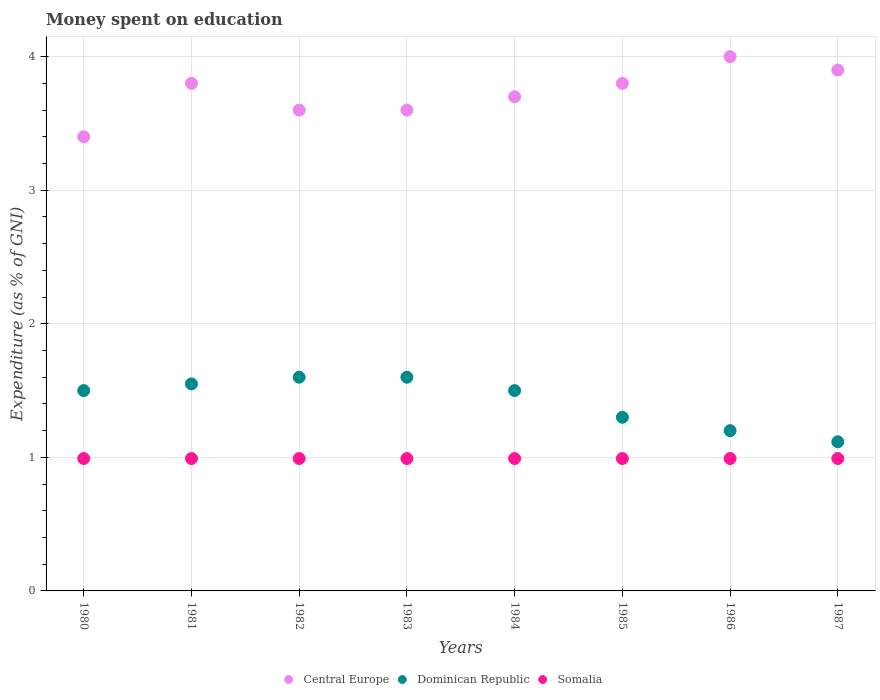Is the number of dotlines equal to the number of legend labels?
Your response must be concise. Yes. What is the amount of money spent on education in Central Europe in 1980?
Your response must be concise. 3.4. Across all years, what is the minimum amount of money spent on education in Dominican Republic?
Provide a succinct answer. 1.12. What is the total amount of money spent on education in Somalia in the graph?
Your answer should be very brief. 7.93. What is the difference between the amount of money spent on education in Dominican Republic in 1984 and the amount of money spent on education in Somalia in 1987?
Your answer should be very brief. 0.51. What is the average amount of money spent on education in Central Europe per year?
Ensure brevity in your answer.  3.72. In the year 1987, what is the difference between the amount of money spent on education in Somalia and amount of money spent on education in Central Europe?
Your answer should be very brief. -2.91. In how many years, is the amount of money spent on education in Dominican Republic greater than 2.8 %?
Offer a very short reply. 0. Is the amount of money spent on education in Dominican Republic in 1981 less than that in 1983?
Make the answer very short. Yes. Is the difference between the amount of money spent on education in Somalia in 1983 and 1986 greater than the difference between the amount of money spent on education in Central Europe in 1983 and 1986?
Make the answer very short. Yes. Is the sum of the amount of money spent on education in Somalia in 1980 and 1983 greater than the maximum amount of money spent on education in Dominican Republic across all years?
Ensure brevity in your answer.  Yes. Is it the case that in every year, the sum of the amount of money spent on education in Central Europe and amount of money spent on education in Dominican Republic  is greater than the amount of money spent on education in Somalia?
Your answer should be compact. Yes. Is the amount of money spent on education in Central Europe strictly greater than the amount of money spent on education in Somalia over the years?
Ensure brevity in your answer.  Yes. How many dotlines are there?
Your answer should be very brief. 3. Are the values on the major ticks of Y-axis written in scientific E-notation?
Your answer should be compact. No. Does the graph contain any zero values?
Your answer should be compact. No. Where does the legend appear in the graph?
Your answer should be very brief. Bottom center. How many legend labels are there?
Provide a short and direct response. 3. What is the title of the graph?
Make the answer very short. Money spent on education. Does "Latin America(developing only)" appear as one of the legend labels in the graph?
Provide a succinct answer. No. What is the label or title of the Y-axis?
Give a very brief answer. Expenditure (as % of GNI). What is the Expenditure (as % of GNI) of Central Europe in 1980?
Ensure brevity in your answer.  3.4. What is the Expenditure (as % of GNI) of Dominican Republic in 1980?
Provide a short and direct response. 1.5. What is the Expenditure (as % of GNI) in Somalia in 1980?
Give a very brief answer. 0.99. What is the Expenditure (as % of GNI) in Central Europe in 1981?
Keep it short and to the point. 3.8. What is the Expenditure (as % of GNI) of Dominican Republic in 1981?
Provide a short and direct response. 1.55. What is the Expenditure (as % of GNI) of Somalia in 1981?
Keep it short and to the point. 0.99. What is the Expenditure (as % of GNI) of Central Europe in 1982?
Your response must be concise. 3.6. What is the Expenditure (as % of GNI) of Somalia in 1982?
Ensure brevity in your answer.  0.99. What is the Expenditure (as % of GNI) of Somalia in 1983?
Offer a terse response. 0.99. What is the Expenditure (as % of GNI) in Central Europe in 1984?
Your answer should be compact. 3.7. What is the Expenditure (as % of GNI) of Dominican Republic in 1984?
Your answer should be very brief. 1.5. What is the Expenditure (as % of GNI) of Somalia in 1984?
Your answer should be compact. 0.99. What is the Expenditure (as % of GNI) of Central Europe in 1985?
Your answer should be very brief. 3.8. What is the Expenditure (as % of GNI) in Somalia in 1985?
Your answer should be very brief. 0.99. What is the Expenditure (as % of GNI) of Somalia in 1986?
Your answer should be very brief. 0.99. What is the Expenditure (as % of GNI) of Central Europe in 1987?
Your response must be concise. 3.9. What is the Expenditure (as % of GNI) in Dominican Republic in 1987?
Give a very brief answer. 1.12. What is the Expenditure (as % of GNI) in Somalia in 1987?
Your response must be concise. 0.99. Across all years, what is the maximum Expenditure (as % of GNI) of Somalia?
Give a very brief answer. 0.99. Across all years, what is the minimum Expenditure (as % of GNI) of Central Europe?
Your answer should be very brief. 3.4. Across all years, what is the minimum Expenditure (as % of GNI) in Dominican Republic?
Offer a terse response. 1.12. Across all years, what is the minimum Expenditure (as % of GNI) in Somalia?
Provide a short and direct response. 0.99. What is the total Expenditure (as % of GNI) of Central Europe in the graph?
Provide a short and direct response. 29.8. What is the total Expenditure (as % of GNI) in Dominican Republic in the graph?
Offer a very short reply. 11.37. What is the total Expenditure (as % of GNI) in Somalia in the graph?
Your answer should be compact. 7.93. What is the difference between the Expenditure (as % of GNI) in Somalia in 1980 and that in 1982?
Make the answer very short. 0. What is the difference between the Expenditure (as % of GNI) in Central Europe in 1980 and that in 1983?
Provide a short and direct response. -0.2. What is the difference between the Expenditure (as % of GNI) in Dominican Republic in 1980 and that in 1983?
Offer a very short reply. -0.1. What is the difference between the Expenditure (as % of GNI) in Central Europe in 1980 and that in 1984?
Provide a succinct answer. -0.3. What is the difference between the Expenditure (as % of GNI) in Dominican Republic in 1980 and that in 1984?
Your answer should be very brief. 0. What is the difference between the Expenditure (as % of GNI) of Somalia in 1980 and that in 1984?
Offer a very short reply. 0. What is the difference between the Expenditure (as % of GNI) in Somalia in 1980 and that in 1985?
Give a very brief answer. 0. What is the difference between the Expenditure (as % of GNI) of Central Europe in 1980 and that in 1986?
Provide a succinct answer. -0.6. What is the difference between the Expenditure (as % of GNI) in Dominican Republic in 1980 and that in 1986?
Your response must be concise. 0.3. What is the difference between the Expenditure (as % of GNI) of Somalia in 1980 and that in 1986?
Your response must be concise. 0. What is the difference between the Expenditure (as % of GNI) in Central Europe in 1980 and that in 1987?
Provide a succinct answer. -0.5. What is the difference between the Expenditure (as % of GNI) in Dominican Republic in 1980 and that in 1987?
Your answer should be compact. 0.38. What is the difference between the Expenditure (as % of GNI) in Somalia in 1980 and that in 1987?
Your answer should be very brief. 0. What is the difference between the Expenditure (as % of GNI) in Central Europe in 1981 and that in 1982?
Provide a short and direct response. 0.2. What is the difference between the Expenditure (as % of GNI) in Dominican Republic in 1981 and that in 1982?
Make the answer very short. -0.05. What is the difference between the Expenditure (as % of GNI) in Somalia in 1981 and that in 1983?
Offer a terse response. 0. What is the difference between the Expenditure (as % of GNI) in Central Europe in 1981 and that in 1984?
Keep it short and to the point. 0.1. What is the difference between the Expenditure (as % of GNI) in Dominican Republic in 1981 and that in 1984?
Give a very brief answer. 0.05. What is the difference between the Expenditure (as % of GNI) in Somalia in 1981 and that in 1984?
Your answer should be compact. 0. What is the difference between the Expenditure (as % of GNI) of Central Europe in 1981 and that in 1985?
Make the answer very short. 0. What is the difference between the Expenditure (as % of GNI) of Dominican Republic in 1981 and that in 1985?
Your answer should be compact. 0.25. What is the difference between the Expenditure (as % of GNI) of Dominican Republic in 1981 and that in 1986?
Keep it short and to the point. 0.35. What is the difference between the Expenditure (as % of GNI) in Somalia in 1981 and that in 1986?
Give a very brief answer. 0. What is the difference between the Expenditure (as % of GNI) in Central Europe in 1981 and that in 1987?
Provide a succinct answer. -0.1. What is the difference between the Expenditure (as % of GNI) of Dominican Republic in 1981 and that in 1987?
Your answer should be very brief. 0.43. What is the difference between the Expenditure (as % of GNI) of Central Europe in 1982 and that in 1984?
Your response must be concise. -0.1. What is the difference between the Expenditure (as % of GNI) in Somalia in 1982 and that in 1984?
Give a very brief answer. 0. What is the difference between the Expenditure (as % of GNI) of Central Europe in 1982 and that in 1986?
Make the answer very short. -0.4. What is the difference between the Expenditure (as % of GNI) of Central Europe in 1982 and that in 1987?
Provide a short and direct response. -0.3. What is the difference between the Expenditure (as % of GNI) in Dominican Republic in 1982 and that in 1987?
Provide a succinct answer. 0.48. What is the difference between the Expenditure (as % of GNI) of Central Europe in 1983 and that in 1984?
Ensure brevity in your answer.  -0.1. What is the difference between the Expenditure (as % of GNI) of Central Europe in 1983 and that in 1985?
Ensure brevity in your answer.  -0.2. What is the difference between the Expenditure (as % of GNI) in Dominican Republic in 1983 and that in 1985?
Offer a terse response. 0.3. What is the difference between the Expenditure (as % of GNI) of Somalia in 1983 and that in 1985?
Offer a terse response. 0. What is the difference between the Expenditure (as % of GNI) of Dominican Republic in 1983 and that in 1986?
Give a very brief answer. 0.4. What is the difference between the Expenditure (as % of GNI) in Central Europe in 1983 and that in 1987?
Ensure brevity in your answer.  -0.3. What is the difference between the Expenditure (as % of GNI) of Dominican Republic in 1983 and that in 1987?
Make the answer very short. 0.48. What is the difference between the Expenditure (as % of GNI) of Somalia in 1984 and that in 1985?
Give a very brief answer. 0. What is the difference between the Expenditure (as % of GNI) in Somalia in 1984 and that in 1986?
Offer a very short reply. 0. What is the difference between the Expenditure (as % of GNI) of Central Europe in 1984 and that in 1987?
Give a very brief answer. -0.2. What is the difference between the Expenditure (as % of GNI) in Dominican Republic in 1984 and that in 1987?
Keep it short and to the point. 0.38. What is the difference between the Expenditure (as % of GNI) of Somalia in 1984 and that in 1987?
Provide a short and direct response. 0. What is the difference between the Expenditure (as % of GNI) of Central Europe in 1985 and that in 1986?
Make the answer very short. -0.2. What is the difference between the Expenditure (as % of GNI) in Somalia in 1985 and that in 1986?
Offer a terse response. 0. What is the difference between the Expenditure (as % of GNI) of Central Europe in 1985 and that in 1987?
Ensure brevity in your answer.  -0.1. What is the difference between the Expenditure (as % of GNI) in Dominican Republic in 1985 and that in 1987?
Provide a short and direct response. 0.18. What is the difference between the Expenditure (as % of GNI) of Central Europe in 1986 and that in 1987?
Your answer should be compact. 0.1. What is the difference between the Expenditure (as % of GNI) of Dominican Republic in 1986 and that in 1987?
Provide a succinct answer. 0.08. What is the difference between the Expenditure (as % of GNI) of Somalia in 1986 and that in 1987?
Your answer should be compact. 0. What is the difference between the Expenditure (as % of GNI) in Central Europe in 1980 and the Expenditure (as % of GNI) in Dominican Republic in 1981?
Provide a short and direct response. 1.85. What is the difference between the Expenditure (as % of GNI) of Central Europe in 1980 and the Expenditure (as % of GNI) of Somalia in 1981?
Keep it short and to the point. 2.41. What is the difference between the Expenditure (as % of GNI) of Dominican Republic in 1980 and the Expenditure (as % of GNI) of Somalia in 1981?
Your answer should be compact. 0.51. What is the difference between the Expenditure (as % of GNI) of Central Europe in 1980 and the Expenditure (as % of GNI) of Somalia in 1982?
Your response must be concise. 2.41. What is the difference between the Expenditure (as % of GNI) in Dominican Republic in 1980 and the Expenditure (as % of GNI) in Somalia in 1982?
Keep it short and to the point. 0.51. What is the difference between the Expenditure (as % of GNI) in Central Europe in 1980 and the Expenditure (as % of GNI) in Somalia in 1983?
Provide a succinct answer. 2.41. What is the difference between the Expenditure (as % of GNI) of Dominican Republic in 1980 and the Expenditure (as % of GNI) of Somalia in 1983?
Your answer should be very brief. 0.51. What is the difference between the Expenditure (as % of GNI) in Central Europe in 1980 and the Expenditure (as % of GNI) in Dominican Republic in 1984?
Give a very brief answer. 1.9. What is the difference between the Expenditure (as % of GNI) in Central Europe in 1980 and the Expenditure (as % of GNI) in Somalia in 1984?
Offer a terse response. 2.41. What is the difference between the Expenditure (as % of GNI) in Dominican Republic in 1980 and the Expenditure (as % of GNI) in Somalia in 1984?
Provide a succinct answer. 0.51. What is the difference between the Expenditure (as % of GNI) in Central Europe in 1980 and the Expenditure (as % of GNI) in Somalia in 1985?
Your answer should be compact. 2.41. What is the difference between the Expenditure (as % of GNI) of Dominican Republic in 1980 and the Expenditure (as % of GNI) of Somalia in 1985?
Provide a short and direct response. 0.51. What is the difference between the Expenditure (as % of GNI) of Central Europe in 1980 and the Expenditure (as % of GNI) of Somalia in 1986?
Provide a short and direct response. 2.41. What is the difference between the Expenditure (as % of GNI) of Dominican Republic in 1980 and the Expenditure (as % of GNI) of Somalia in 1986?
Offer a terse response. 0.51. What is the difference between the Expenditure (as % of GNI) of Central Europe in 1980 and the Expenditure (as % of GNI) of Dominican Republic in 1987?
Your answer should be compact. 2.28. What is the difference between the Expenditure (as % of GNI) of Central Europe in 1980 and the Expenditure (as % of GNI) of Somalia in 1987?
Offer a terse response. 2.41. What is the difference between the Expenditure (as % of GNI) in Dominican Republic in 1980 and the Expenditure (as % of GNI) in Somalia in 1987?
Make the answer very short. 0.51. What is the difference between the Expenditure (as % of GNI) in Central Europe in 1981 and the Expenditure (as % of GNI) in Somalia in 1982?
Provide a succinct answer. 2.81. What is the difference between the Expenditure (as % of GNI) of Dominican Republic in 1981 and the Expenditure (as % of GNI) of Somalia in 1982?
Offer a terse response. 0.56. What is the difference between the Expenditure (as % of GNI) of Central Europe in 1981 and the Expenditure (as % of GNI) of Dominican Republic in 1983?
Provide a short and direct response. 2.2. What is the difference between the Expenditure (as % of GNI) in Central Europe in 1981 and the Expenditure (as % of GNI) in Somalia in 1983?
Make the answer very short. 2.81. What is the difference between the Expenditure (as % of GNI) of Dominican Republic in 1981 and the Expenditure (as % of GNI) of Somalia in 1983?
Offer a very short reply. 0.56. What is the difference between the Expenditure (as % of GNI) of Central Europe in 1981 and the Expenditure (as % of GNI) of Dominican Republic in 1984?
Your answer should be very brief. 2.3. What is the difference between the Expenditure (as % of GNI) of Central Europe in 1981 and the Expenditure (as % of GNI) of Somalia in 1984?
Your response must be concise. 2.81. What is the difference between the Expenditure (as % of GNI) of Dominican Republic in 1981 and the Expenditure (as % of GNI) of Somalia in 1984?
Make the answer very short. 0.56. What is the difference between the Expenditure (as % of GNI) of Central Europe in 1981 and the Expenditure (as % of GNI) of Dominican Republic in 1985?
Offer a terse response. 2.5. What is the difference between the Expenditure (as % of GNI) of Central Europe in 1981 and the Expenditure (as % of GNI) of Somalia in 1985?
Your answer should be very brief. 2.81. What is the difference between the Expenditure (as % of GNI) of Dominican Republic in 1981 and the Expenditure (as % of GNI) of Somalia in 1985?
Provide a short and direct response. 0.56. What is the difference between the Expenditure (as % of GNI) of Central Europe in 1981 and the Expenditure (as % of GNI) of Somalia in 1986?
Provide a short and direct response. 2.81. What is the difference between the Expenditure (as % of GNI) in Dominican Republic in 1981 and the Expenditure (as % of GNI) in Somalia in 1986?
Ensure brevity in your answer.  0.56. What is the difference between the Expenditure (as % of GNI) in Central Europe in 1981 and the Expenditure (as % of GNI) in Dominican Republic in 1987?
Your answer should be very brief. 2.68. What is the difference between the Expenditure (as % of GNI) in Central Europe in 1981 and the Expenditure (as % of GNI) in Somalia in 1987?
Your response must be concise. 2.81. What is the difference between the Expenditure (as % of GNI) in Dominican Republic in 1981 and the Expenditure (as % of GNI) in Somalia in 1987?
Offer a very short reply. 0.56. What is the difference between the Expenditure (as % of GNI) of Central Europe in 1982 and the Expenditure (as % of GNI) of Dominican Republic in 1983?
Provide a short and direct response. 2. What is the difference between the Expenditure (as % of GNI) of Central Europe in 1982 and the Expenditure (as % of GNI) of Somalia in 1983?
Ensure brevity in your answer.  2.61. What is the difference between the Expenditure (as % of GNI) of Dominican Republic in 1982 and the Expenditure (as % of GNI) of Somalia in 1983?
Give a very brief answer. 0.61. What is the difference between the Expenditure (as % of GNI) of Central Europe in 1982 and the Expenditure (as % of GNI) of Somalia in 1984?
Ensure brevity in your answer.  2.61. What is the difference between the Expenditure (as % of GNI) of Dominican Republic in 1982 and the Expenditure (as % of GNI) of Somalia in 1984?
Provide a succinct answer. 0.61. What is the difference between the Expenditure (as % of GNI) of Central Europe in 1982 and the Expenditure (as % of GNI) of Dominican Republic in 1985?
Ensure brevity in your answer.  2.3. What is the difference between the Expenditure (as % of GNI) of Central Europe in 1982 and the Expenditure (as % of GNI) of Somalia in 1985?
Your answer should be very brief. 2.61. What is the difference between the Expenditure (as % of GNI) of Dominican Republic in 1982 and the Expenditure (as % of GNI) of Somalia in 1985?
Your answer should be compact. 0.61. What is the difference between the Expenditure (as % of GNI) in Central Europe in 1982 and the Expenditure (as % of GNI) in Somalia in 1986?
Make the answer very short. 2.61. What is the difference between the Expenditure (as % of GNI) of Dominican Republic in 1982 and the Expenditure (as % of GNI) of Somalia in 1986?
Make the answer very short. 0.61. What is the difference between the Expenditure (as % of GNI) in Central Europe in 1982 and the Expenditure (as % of GNI) in Dominican Republic in 1987?
Give a very brief answer. 2.48. What is the difference between the Expenditure (as % of GNI) of Central Europe in 1982 and the Expenditure (as % of GNI) of Somalia in 1987?
Ensure brevity in your answer.  2.61. What is the difference between the Expenditure (as % of GNI) in Dominican Republic in 1982 and the Expenditure (as % of GNI) in Somalia in 1987?
Provide a short and direct response. 0.61. What is the difference between the Expenditure (as % of GNI) of Central Europe in 1983 and the Expenditure (as % of GNI) of Somalia in 1984?
Your response must be concise. 2.61. What is the difference between the Expenditure (as % of GNI) in Dominican Republic in 1983 and the Expenditure (as % of GNI) in Somalia in 1984?
Your answer should be very brief. 0.61. What is the difference between the Expenditure (as % of GNI) in Central Europe in 1983 and the Expenditure (as % of GNI) in Dominican Republic in 1985?
Make the answer very short. 2.3. What is the difference between the Expenditure (as % of GNI) in Central Europe in 1983 and the Expenditure (as % of GNI) in Somalia in 1985?
Your response must be concise. 2.61. What is the difference between the Expenditure (as % of GNI) in Dominican Republic in 1983 and the Expenditure (as % of GNI) in Somalia in 1985?
Your answer should be compact. 0.61. What is the difference between the Expenditure (as % of GNI) of Central Europe in 1983 and the Expenditure (as % of GNI) of Dominican Republic in 1986?
Your answer should be very brief. 2.4. What is the difference between the Expenditure (as % of GNI) of Central Europe in 1983 and the Expenditure (as % of GNI) of Somalia in 1986?
Provide a short and direct response. 2.61. What is the difference between the Expenditure (as % of GNI) of Dominican Republic in 1983 and the Expenditure (as % of GNI) of Somalia in 1986?
Your response must be concise. 0.61. What is the difference between the Expenditure (as % of GNI) of Central Europe in 1983 and the Expenditure (as % of GNI) of Dominican Republic in 1987?
Your response must be concise. 2.48. What is the difference between the Expenditure (as % of GNI) in Central Europe in 1983 and the Expenditure (as % of GNI) in Somalia in 1987?
Your answer should be very brief. 2.61. What is the difference between the Expenditure (as % of GNI) in Dominican Republic in 1983 and the Expenditure (as % of GNI) in Somalia in 1987?
Provide a short and direct response. 0.61. What is the difference between the Expenditure (as % of GNI) of Central Europe in 1984 and the Expenditure (as % of GNI) of Dominican Republic in 1985?
Offer a very short reply. 2.4. What is the difference between the Expenditure (as % of GNI) in Central Europe in 1984 and the Expenditure (as % of GNI) in Somalia in 1985?
Your response must be concise. 2.71. What is the difference between the Expenditure (as % of GNI) of Dominican Republic in 1984 and the Expenditure (as % of GNI) of Somalia in 1985?
Your answer should be compact. 0.51. What is the difference between the Expenditure (as % of GNI) of Central Europe in 1984 and the Expenditure (as % of GNI) of Dominican Republic in 1986?
Offer a terse response. 2.5. What is the difference between the Expenditure (as % of GNI) of Central Europe in 1984 and the Expenditure (as % of GNI) of Somalia in 1986?
Provide a short and direct response. 2.71. What is the difference between the Expenditure (as % of GNI) of Dominican Republic in 1984 and the Expenditure (as % of GNI) of Somalia in 1986?
Your answer should be very brief. 0.51. What is the difference between the Expenditure (as % of GNI) in Central Europe in 1984 and the Expenditure (as % of GNI) in Dominican Republic in 1987?
Keep it short and to the point. 2.58. What is the difference between the Expenditure (as % of GNI) in Central Europe in 1984 and the Expenditure (as % of GNI) in Somalia in 1987?
Your answer should be very brief. 2.71. What is the difference between the Expenditure (as % of GNI) of Dominican Republic in 1984 and the Expenditure (as % of GNI) of Somalia in 1987?
Your answer should be very brief. 0.51. What is the difference between the Expenditure (as % of GNI) of Central Europe in 1985 and the Expenditure (as % of GNI) of Somalia in 1986?
Your answer should be very brief. 2.81. What is the difference between the Expenditure (as % of GNI) in Dominican Republic in 1985 and the Expenditure (as % of GNI) in Somalia in 1986?
Give a very brief answer. 0.31. What is the difference between the Expenditure (as % of GNI) in Central Europe in 1985 and the Expenditure (as % of GNI) in Dominican Republic in 1987?
Ensure brevity in your answer.  2.68. What is the difference between the Expenditure (as % of GNI) in Central Europe in 1985 and the Expenditure (as % of GNI) in Somalia in 1987?
Provide a succinct answer. 2.81. What is the difference between the Expenditure (as % of GNI) in Dominican Republic in 1985 and the Expenditure (as % of GNI) in Somalia in 1987?
Your answer should be compact. 0.31. What is the difference between the Expenditure (as % of GNI) in Central Europe in 1986 and the Expenditure (as % of GNI) in Dominican Republic in 1987?
Provide a short and direct response. 2.88. What is the difference between the Expenditure (as % of GNI) in Central Europe in 1986 and the Expenditure (as % of GNI) in Somalia in 1987?
Provide a short and direct response. 3.01. What is the difference between the Expenditure (as % of GNI) of Dominican Republic in 1986 and the Expenditure (as % of GNI) of Somalia in 1987?
Make the answer very short. 0.21. What is the average Expenditure (as % of GNI) in Central Europe per year?
Make the answer very short. 3.73. What is the average Expenditure (as % of GNI) of Dominican Republic per year?
Ensure brevity in your answer.  1.42. What is the average Expenditure (as % of GNI) of Somalia per year?
Provide a short and direct response. 0.99. In the year 1980, what is the difference between the Expenditure (as % of GNI) in Central Europe and Expenditure (as % of GNI) in Dominican Republic?
Offer a very short reply. 1.9. In the year 1980, what is the difference between the Expenditure (as % of GNI) of Central Europe and Expenditure (as % of GNI) of Somalia?
Offer a very short reply. 2.41. In the year 1980, what is the difference between the Expenditure (as % of GNI) of Dominican Republic and Expenditure (as % of GNI) of Somalia?
Your response must be concise. 0.51. In the year 1981, what is the difference between the Expenditure (as % of GNI) of Central Europe and Expenditure (as % of GNI) of Dominican Republic?
Your answer should be very brief. 2.25. In the year 1981, what is the difference between the Expenditure (as % of GNI) of Central Europe and Expenditure (as % of GNI) of Somalia?
Your answer should be very brief. 2.81. In the year 1981, what is the difference between the Expenditure (as % of GNI) of Dominican Republic and Expenditure (as % of GNI) of Somalia?
Offer a very short reply. 0.56. In the year 1982, what is the difference between the Expenditure (as % of GNI) of Central Europe and Expenditure (as % of GNI) of Dominican Republic?
Your answer should be very brief. 2. In the year 1982, what is the difference between the Expenditure (as % of GNI) in Central Europe and Expenditure (as % of GNI) in Somalia?
Offer a terse response. 2.61. In the year 1982, what is the difference between the Expenditure (as % of GNI) of Dominican Republic and Expenditure (as % of GNI) of Somalia?
Make the answer very short. 0.61. In the year 1983, what is the difference between the Expenditure (as % of GNI) in Central Europe and Expenditure (as % of GNI) in Somalia?
Your response must be concise. 2.61. In the year 1983, what is the difference between the Expenditure (as % of GNI) in Dominican Republic and Expenditure (as % of GNI) in Somalia?
Make the answer very short. 0.61. In the year 1984, what is the difference between the Expenditure (as % of GNI) in Central Europe and Expenditure (as % of GNI) in Dominican Republic?
Offer a very short reply. 2.2. In the year 1984, what is the difference between the Expenditure (as % of GNI) of Central Europe and Expenditure (as % of GNI) of Somalia?
Your answer should be compact. 2.71. In the year 1984, what is the difference between the Expenditure (as % of GNI) in Dominican Republic and Expenditure (as % of GNI) in Somalia?
Your answer should be compact. 0.51. In the year 1985, what is the difference between the Expenditure (as % of GNI) in Central Europe and Expenditure (as % of GNI) in Dominican Republic?
Provide a succinct answer. 2.5. In the year 1985, what is the difference between the Expenditure (as % of GNI) of Central Europe and Expenditure (as % of GNI) of Somalia?
Provide a succinct answer. 2.81. In the year 1985, what is the difference between the Expenditure (as % of GNI) of Dominican Republic and Expenditure (as % of GNI) of Somalia?
Your response must be concise. 0.31. In the year 1986, what is the difference between the Expenditure (as % of GNI) in Central Europe and Expenditure (as % of GNI) in Dominican Republic?
Offer a terse response. 2.8. In the year 1986, what is the difference between the Expenditure (as % of GNI) of Central Europe and Expenditure (as % of GNI) of Somalia?
Offer a terse response. 3.01. In the year 1986, what is the difference between the Expenditure (as % of GNI) of Dominican Republic and Expenditure (as % of GNI) of Somalia?
Ensure brevity in your answer.  0.21. In the year 1987, what is the difference between the Expenditure (as % of GNI) of Central Europe and Expenditure (as % of GNI) of Dominican Republic?
Provide a succinct answer. 2.78. In the year 1987, what is the difference between the Expenditure (as % of GNI) of Central Europe and Expenditure (as % of GNI) of Somalia?
Ensure brevity in your answer.  2.91. In the year 1987, what is the difference between the Expenditure (as % of GNI) of Dominican Republic and Expenditure (as % of GNI) of Somalia?
Offer a terse response. 0.13. What is the ratio of the Expenditure (as % of GNI) in Central Europe in 1980 to that in 1981?
Provide a short and direct response. 0.89. What is the ratio of the Expenditure (as % of GNI) of Central Europe in 1980 to that in 1982?
Your answer should be compact. 0.94. What is the ratio of the Expenditure (as % of GNI) in Somalia in 1980 to that in 1982?
Make the answer very short. 1. What is the ratio of the Expenditure (as % of GNI) of Central Europe in 1980 to that in 1983?
Offer a very short reply. 0.94. What is the ratio of the Expenditure (as % of GNI) in Dominican Republic in 1980 to that in 1983?
Provide a succinct answer. 0.94. What is the ratio of the Expenditure (as % of GNI) in Somalia in 1980 to that in 1983?
Give a very brief answer. 1. What is the ratio of the Expenditure (as % of GNI) in Central Europe in 1980 to that in 1984?
Offer a very short reply. 0.92. What is the ratio of the Expenditure (as % of GNI) in Somalia in 1980 to that in 1984?
Make the answer very short. 1. What is the ratio of the Expenditure (as % of GNI) of Central Europe in 1980 to that in 1985?
Your response must be concise. 0.89. What is the ratio of the Expenditure (as % of GNI) of Dominican Republic in 1980 to that in 1985?
Provide a succinct answer. 1.15. What is the ratio of the Expenditure (as % of GNI) of Somalia in 1980 to that in 1986?
Your answer should be compact. 1. What is the ratio of the Expenditure (as % of GNI) in Central Europe in 1980 to that in 1987?
Provide a succinct answer. 0.87. What is the ratio of the Expenditure (as % of GNI) of Dominican Republic in 1980 to that in 1987?
Offer a terse response. 1.34. What is the ratio of the Expenditure (as % of GNI) in Central Europe in 1981 to that in 1982?
Give a very brief answer. 1.06. What is the ratio of the Expenditure (as % of GNI) in Dominican Republic in 1981 to that in 1982?
Make the answer very short. 0.97. What is the ratio of the Expenditure (as % of GNI) in Somalia in 1981 to that in 1982?
Provide a short and direct response. 1. What is the ratio of the Expenditure (as % of GNI) in Central Europe in 1981 to that in 1983?
Give a very brief answer. 1.06. What is the ratio of the Expenditure (as % of GNI) of Dominican Republic in 1981 to that in 1983?
Give a very brief answer. 0.97. What is the ratio of the Expenditure (as % of GNI) in Somalia in 1981 to that in 1983?
Provide a succinct answer. 1. What is the ratio of the Expenditure (as % of GNI) in Dominican Republic in 1981 to that in 1984?
Ensure brevity in your answer.  1.03. What is the ratio of the Expenditure (as % of GNI) in Somalia in 1981 to that in 1984?
Your answer should be very brief. 1. What is the ratio of the Expenditure (as % of GNI) of Dominican Republic in 1981 to that in 1985?
Ensure brevity in your answer.  1.19. What is the ratio of the Expenditure (as % of GNI) of Central Europe in 1981 to that in 1986?
Give a very brief answer. 0.95. What is the ratio of the Expenditure (as % of GNI) in Dominican Republic in 1981 to that in 1986?
Provide a short and direct response. 1.29. What is the ratio of the Expenditure (as % of GNI) in Central Europe in 1981 to that in 1987?
Ensure brevity in your answer.  0.97. What is the ratio of the Expenditure (as % of GNI) in Dominican Republic in 1981 to that in 1987?
Provide a succinct answer. 1.39. What is the ratio of the Expenditure (as % of GNI) in Somalia in 1981 to that in 1987?
Your answer should be very brief. 1. What is the ratio of the Expenditure (as % of GNI) in Dominican Republic in 1982 to that in 1983?
Your answer should be compact. 1. What is the ratio of the Expenditure (as % of GNI) in Central Europe in 1982 to that in 1984?
Make the answer very short. 0.97. What is the ratio of the Expenditure (as % of GNI) in Dominican Republic in 1982 to that in 1984?
Ensure brevity in your answer.  1.07. What is the ratio of the Expenditure (as % of GNI) in Somalia in 1982 to that in 1984?
Give a very brief answer. 1. What is the ratio of the Expenditure (as % of GNI) in Central Europe in 1982 to that in 1985?
Make the answer very short. 0.95. What is the ratio of the Expenditure (as % of GNI) in Dominican Republic in 1982 to that in 1985?
Keep it short and to the point. 1.23. What is the ratio of the Expenditure (as % of GNI) of Somalia in 1982 to that in 1985?
Ensure brevity in your answer.  1. What is the ratio of the Expenditure (as % of GNI) in Dominican Republic in 1982 to that in 1986?
Provide a short and direct response. 1.33. What is the ratio of the Expenditure (as % of GNI) in Dominican Republic in 1982 to that in 1987?
Keep it short and to the point. 1.43. What is the ratio of the Expenditure (as % of GNI) of Somalia in 1982 to that in 1987?
Your response must be concise. 1. What is the ratio of the Expenditure (as % of GNI) in Dominican Republic in 1983 to that in 1984?
Your answer should be very brief. 1.07. What is the ratio of the Expenditure (as % of GNI) of Somalia in 1983 to that in 1984?
Give a very brief answer. 1. What is the ratio of the Expenditure (as % of GNI) of Dominican Republic in 1983 to that in 1985?
Ensure brevity in your answer.  1.23. What is the ratio of the Expenditure (as % of GNI) of Central Europe in 1983 to that in 1986?
Offer a terse response. 0.9. What is the ratio of the Expenditure (as % of GNI) in Somalia in 1983 to that in 1986?
Your answer should be compact. 1. What is the ratio of the Expenditure (as % of GNI) of Dominican Republic in 1983 to that in 1987?
Ensure brevity in your answer.  1.43. What is the ratio of the Expenditure (as % of GNI) of Central Europe in 1984 to that in 1985?
Keep it short and to the point. 0.97. What is the ratio of the Expenditure (as % of GNI) in Dominican Republic in 1984 to that in 1985?
Provide a succinct answer. 1.15. What is the ratio of the Expenditure (as % of GNI) in Somalia in 1984 to that in 1985?
Offer a very short reply. 1. What is the ratio of the Expenditure (as % of GNI) in Central Europe in 1984 to that in 1986?
Make the answer very short. 0.93. What is the ratio of the Expenditure (as % of GNI) of Dominican Republic in 1984 to that in 1986?
Provide a short and direct response. 1.25. What is the ratio of the Expenditure (as % of GNI) in Somalia in 1984 to that in 1986?
Make the answer very short. 1. What is the ratio of the Expenditure (as % of GNI) of Central Europe in 1984 to that in 1987?
Your answer should be very brief. 0.95. What is the ratio of the Expenditure (as % of GNI) of Dominican Republic in 1984 to that in 1987?
Offer a terse response. 1.34. What is the ratio of the Expenditure (as % of GNI) in Somalia in 1984 to that in 1987?
Ensure brevity in your answer.  1. What is the ratio of the Expenditure (as % of GNI) of Central Europe in 1985 to that in 1986?
Offer a terse response. 0.95. What is the ratio of the Expenditure (as % of GNI) in Dominican Republic in 1985 to that in 1986?
Ensure brevity in your answer.  1.08. What is the ratio of the Expenditure (as % of GNI) in Somalia in 1985 to that in 1986?
Your answer should be very brief. 1. What is the ratio of the Expenditure (as % of GNI) in Central Europe in 1985 to that in 1987?
Offer a very short reply. 0.97. What is the ratio of the Expenditure (as % of GNI) in Dominican Republic in 1985 to that in 1987?
Provide a succinct answer. 1.16. What is the ratio of the Expenditure (as % of GNI) in Central Europe in 1986 to that in 1987?
Offer a terse response. 1.03. What is the ratio of the Expenditure (as % of GNI) of Dominican Republic in 1986 to that in 1987?
Your answer should be very brief. 1.07. What is the difference between the highest and the second highest Expenditure (as % of GNI) of Central Europe?
Ensure brevity in your answer.  0.1. What is the difference between the highest and the second highest Expenditure (as % of GNI) of Somalia?
Provide a short and direct response. 0. What is the difference between the highest and the lowest Expenditure (as % of GNI) in Dominican Republic?
Your answer should be very brief. 0.48. What is the difference between the highest and the lowest Expenditure (as % of GNI) in Somalia?
Your answer should be very brief. 0. 